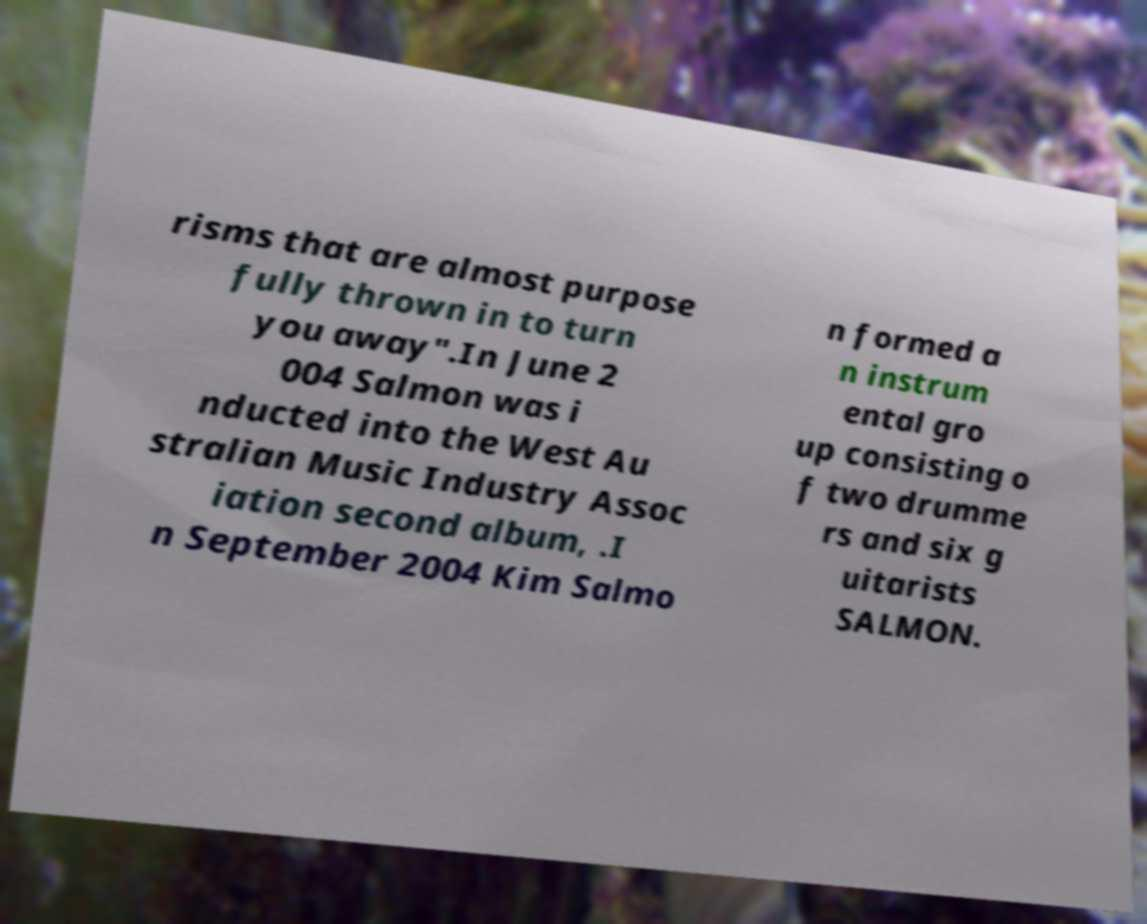Please read and relay the text visible in this image. What does it say? risms that are almost purpose fully thrown in to turn you away".In June 2 004 Salmon was i nducted into the West Au stralian Music Industry Assoc iation second album, .I n September 2004 Kim Salmo n formed a n instrum ental gro up consisting o f two drumme rs and six g uitarists SALMON. 